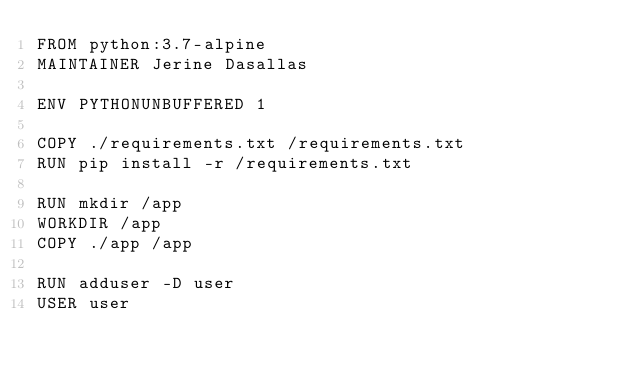<code> <loc_0><loc_0><loc_500><loc_500><_Dockerfile_>FROM python:3.7-alpine
MAINTAINER Jerine Dasallas

ENV PYTHONUNBUFFERED 1

COPY ./requirements.txt /requirements.txt
RUN pip install -r /requirements.txt

RUN mkdir /app
WORKDIR /app
COPY ./app /app

RUN adduser -D user
USER user
</code> 